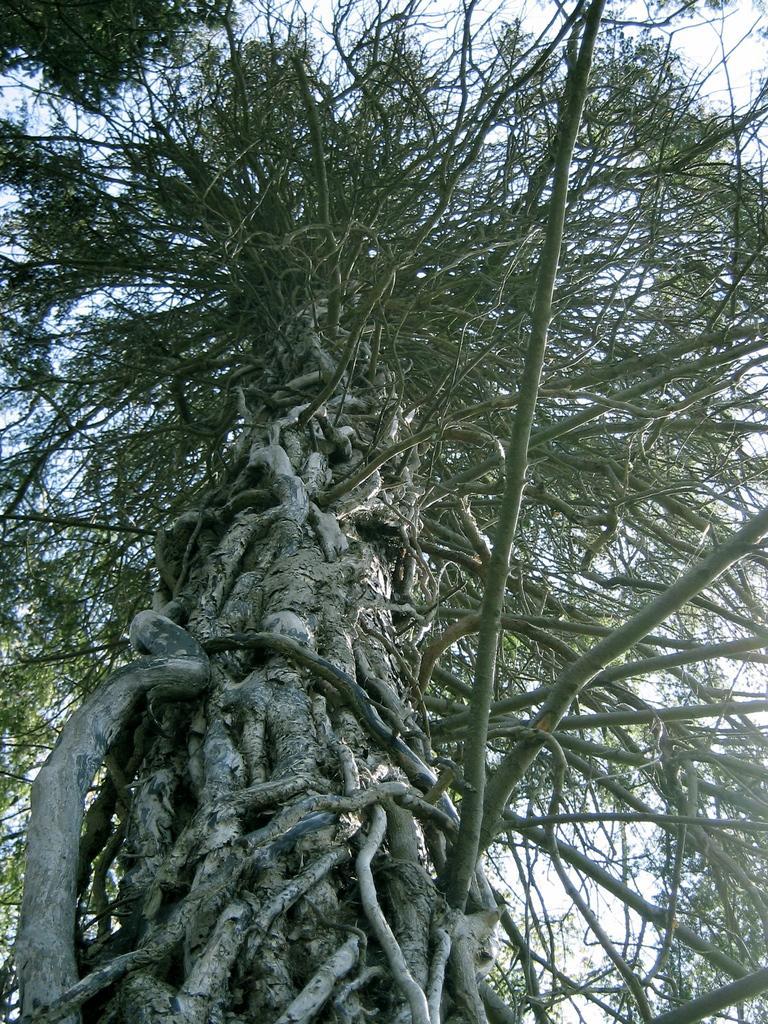Please provide a concise description of this image. In the center of this picture we can see an object seems to be the tree and we can see some other objects. In the background we can see the sky and this picture is clicked outside. 